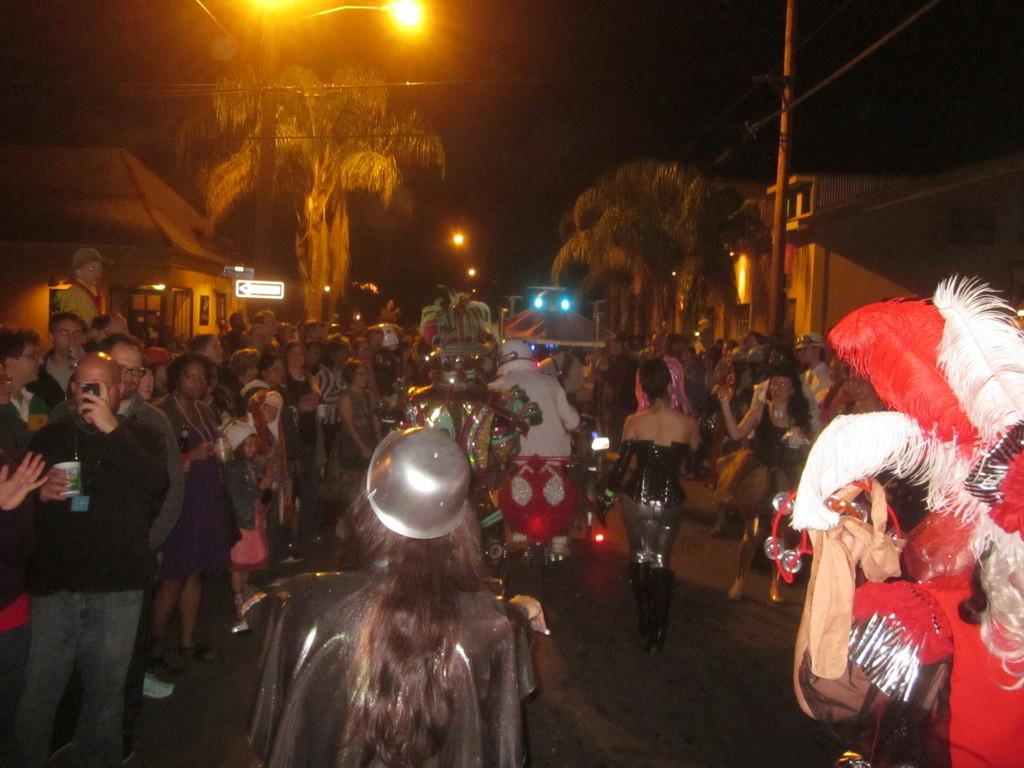Who or what can be seen in the image? There are people in the image. What type of structure is present in the image? There is a house in the image. What type of natural elements are visible in the image? There are trees in the image. What type of illumination is present in the image? There are lights in the image. What type of nut is being cracked by the people in the image? There is no nut present in the image, and the people are not shown cracking any nuts. 